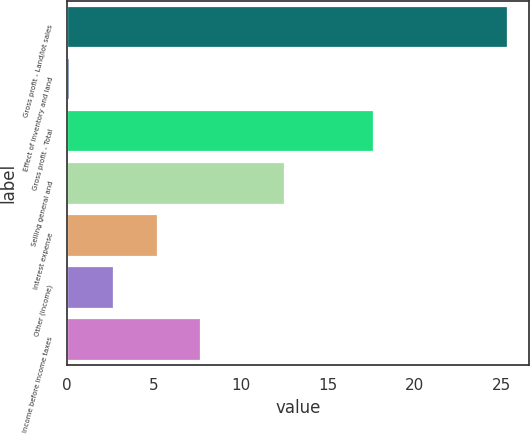<chart> <loc_0><loc_0><loc_500><loc_500><bar_chart><fcel>Gross profit - Land/lot sales<fcel>Effect of inventory and land<fcel>Gross profit - Total<fcel>Selling general and<fcel>Interest expense<fcel>Other (income)<fcel>Income before income taxes<nl><fcel>25.3<fcel>0.1<fcel>17.6<fcel>12.5<fcel>5.14<fcel>2.62<fcel>7.66<nl></chart> 